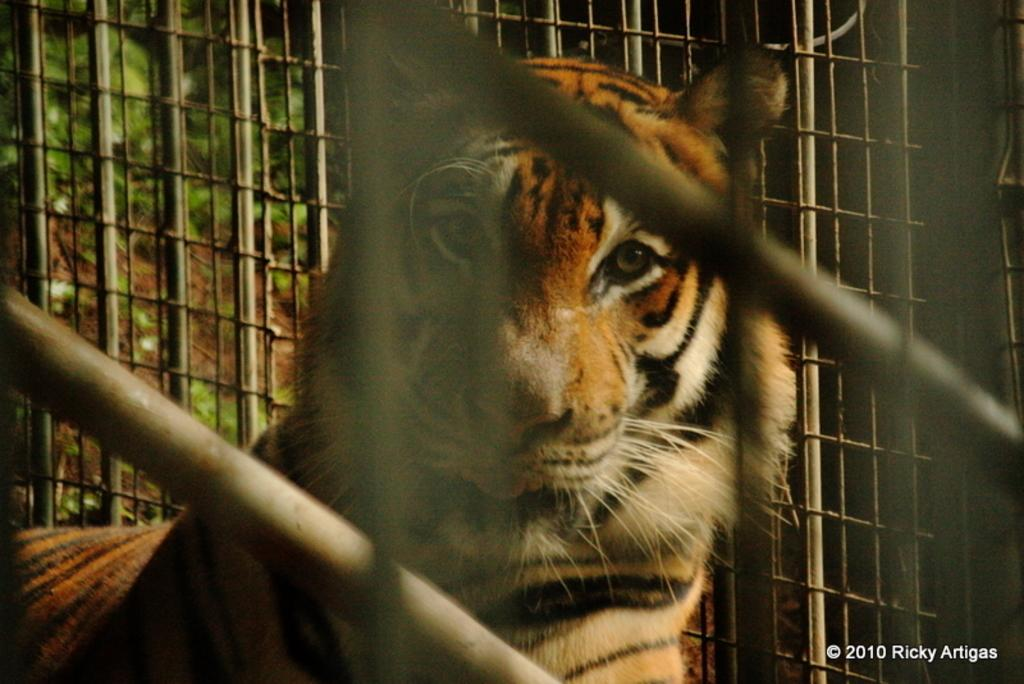What type of animal is in the image? The type of animal cannot be determined from the provided facts. What can be seen through the window in the image? Trees are visible through the window in the image. Is the animal reading a notebook while standing on a scale in the image? There is no mention of a notebook, scale, or the animal reading in the provided facts. 